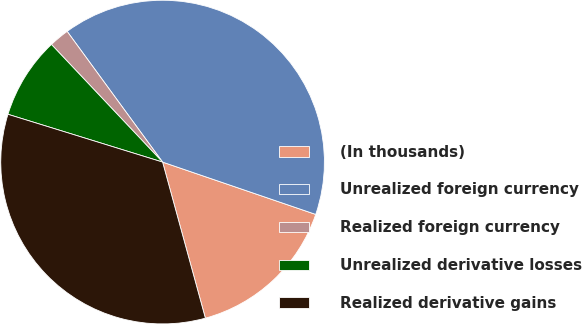Convert chart to OTSL. <chart><loc_0><loc_0><loc_500><loc_500><pie_chart><fcel>(In thousands)<fcel>Unrealized foreign currency<fcel>Realized foreign currency<fcel>Unrealized derivative losses<fcel>Realized derivative gains<nl><fcel>15.5%<fcel>40.28%<fcel>2.01%<fcel>8.18%<fcel>34.03%<nl></chart> 